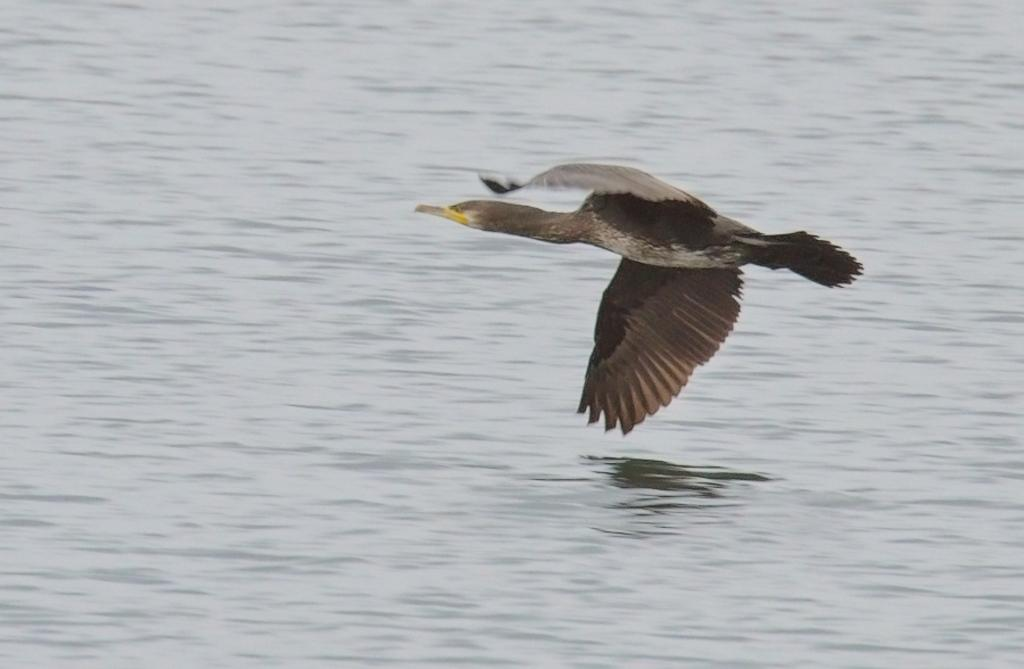What is: What is the main subject of the image? The main subject of the image is a bird flying. What can be seen at the bottom of the image? There is a river at the bottom of the image. How many bottles are visible in the image? There are no bottles present in the image. 